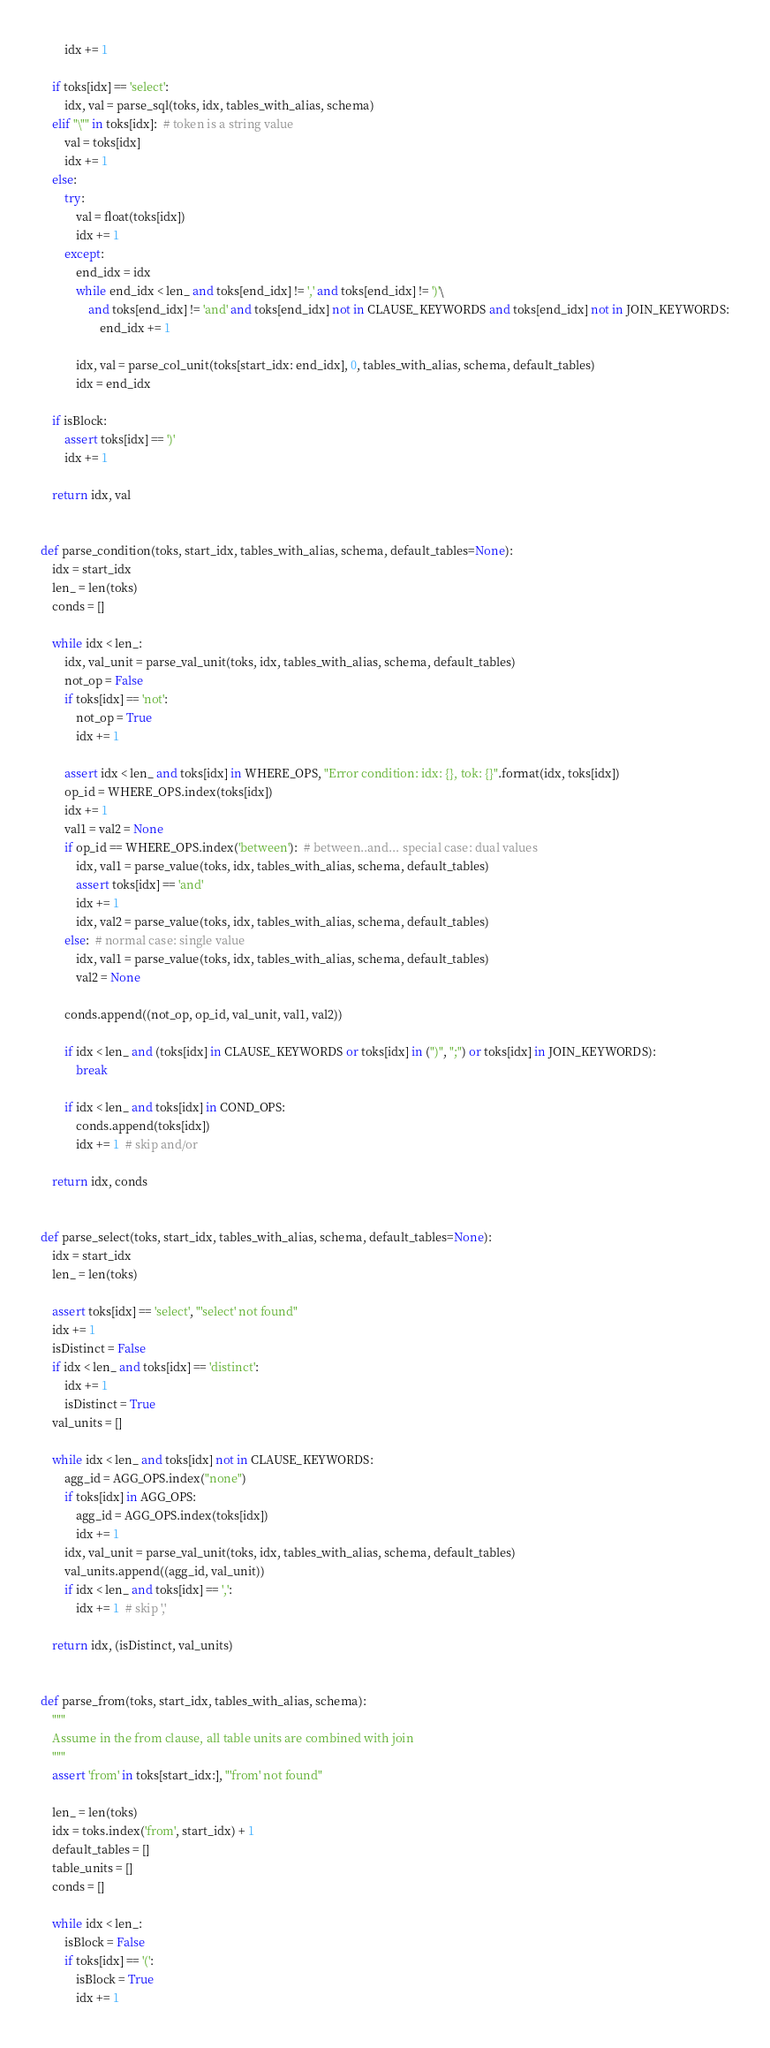<code> <loc_0><loc_0><loc_500><loc_500><_Python_>        idx += 1

    if toks[idx] == 'select':
        idx, val = parse_sql(toks, idx, tables_with_alias, schema)
    elif "\"" in toks[idx]:  # token is a string value
        val = toks[idx]
        idx += 1
    else:
        try:
            val = float(toks[idx])
            idx += 1
        except:
            end_idx = idx
            while end_idx < len_ and toks[end_idx] != ',' and toks[end_idx] != ')'\
                and toks[end_idx] != 'and' and toks[end_idx] not in CLAUSE_KEYWORDS and toks[end_idx] not in JOIN_KEYWORDS:
                    end_idx += 1

            idx, val = parse_col_unit(toks[start_idx: end_idx], 0, tables_with_alias, schema, default_tables)
            idx = end_idx

    if isBlock:
        assert toks[idx] == ')'
        idx += 1

    return idx, val


def parse_condition(toks, start_idx, tables_with_alias, schema, default_tables=None):
    idx = start_idx
    len_ = len(toks)
    conds = []

    while idx < len_:
        idx, val_unit = parse_val_unit(toks, idx, tables_with_alias, schema, default_tables)
        not_op = False
        if toks[idx] == 'not':
            not_op = True
            idx += 1

        assert idx < len_ and toks[idx] in WHERE_OPS, "Error condition: idx: {}, tok: {}".format(idx, toks[idx])
        op_id = WHERE_OPS.index(toks[idx])
        idx += 1
        val1 = val2 = None
        if op_id == WHERE_OPS.index('between'):  # between..and... special case: dual values
            idx, val1 = parse_value(toks, idx, tables_with_alias, schema, default_tables)
            assert toks[idx] == 'and'
            idx += 1
            idx, val2 = parse_value(toks, idx, tables_with_alias, schema, default_tables)
        else:  # normal case: single value
            idx, val1 = parse_value(toks, idx, tables_with_alias, schema, default_tables)
            val2 = None

        conds.append((not_op, op_id, val_unit, val1, val2))

        if idx < len_ and (toks[idx] in CLAUSE_KEYWORDS or toks[idx] in (")", ";") or toks[idx] in JOIN_KEYWORDS):
            break

        if idx < len_ and toks[idx] in COND_OPS:
            conds.append(toks[idx])
            idx += 1  # skip and/or

    return idx, conds


def parse_select(toks, start_idx, tables_with_alias, schema, default_tables=None):
    idx = start_idx
    len_ = len(toks)

    assert toks[idx] == 'select', "'select' not found"
    idx += 1
    isDistinct = False
    if idx < len_ and toks[idx] == 'distinct':
        idx += 1
        isDistinct = True
    val_units = []

    while idx < len_ and toks[idx] not in CLAUSE_KEYWORDS:
        agg_id = AGG_OPS.index("none")
        if toks[idx] in AGG_OPS:
            agg_id = AGG_OPS.index(toks[idx])
            idx += 1
        idx, val_unit = parse_val_unit(toks, idx, tables_with_alias, schema, default_tables)
        val_units.append((agg_id, val_unit))
        if idx < len_ and toks[idx] == ',':
            idx += 1  # skip ','

    return idx, (isDistinct, val_units)


def parse_from(toks, start_idx, tables_with_alias, schema):
    """
    Assume in the from clause, all table units are combined with join
    """
    assert 'from' in toks[start_idx:], "'from' not found"

    len_ = len(toks)
    idx = toks.index('from', start_idx) + 1
    default_tables = []
    table_units = []
    conds = []

    while idx < len_:
        isBlock = False
        if toks[idx] == '(':
            isBlock = True
            idx += 1
</code> 